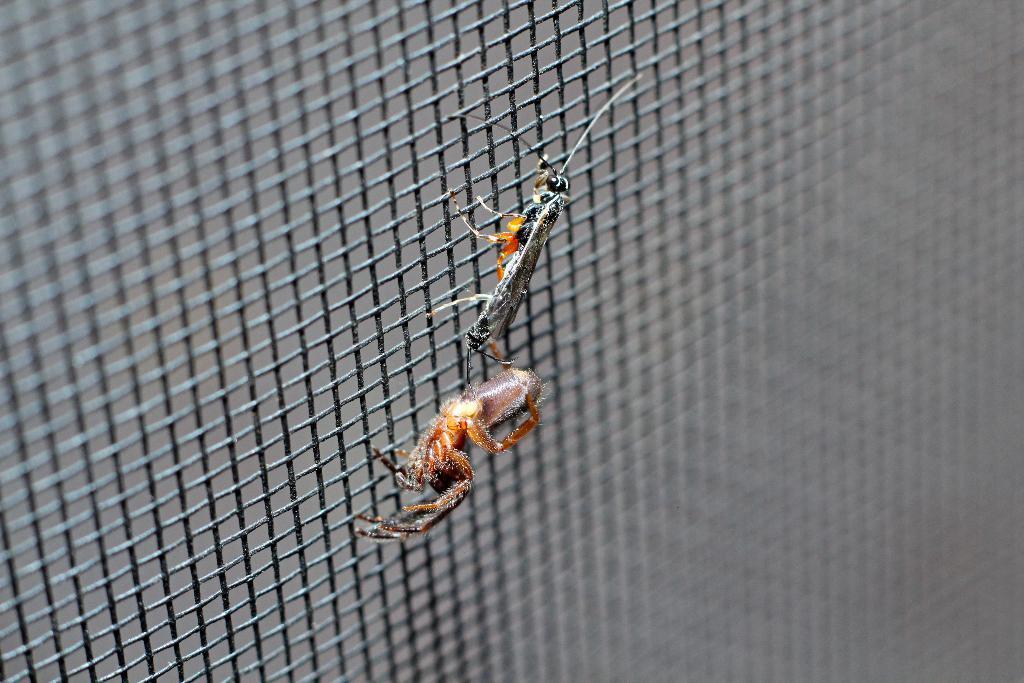Can you describe this image briefly? In this picture we can see two insects on a grill. 